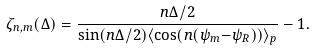<formula> <loc_0><loc_0><loc_500><loc_500>\zeta _ { n , m } ( \Delta ) = \frac { n \Delta / 2 } { \sin ( n \Delta / 2 ) \langle \cos ( n ( \psi _ { m } { - } \psi _ { R } ) ) \rangle _ { p } } - 1 .</formula> 